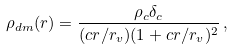<formula> <loc_0><loc_0><loc_500><loc_500>\rho _ { d m } ( r ) = \frac { \rho _ { c } \delta _ { c } } { ( c r / r _ { v } ) ( 1 + c r / r _ { v } ) ^ { 2 } } \, ,</formula> 